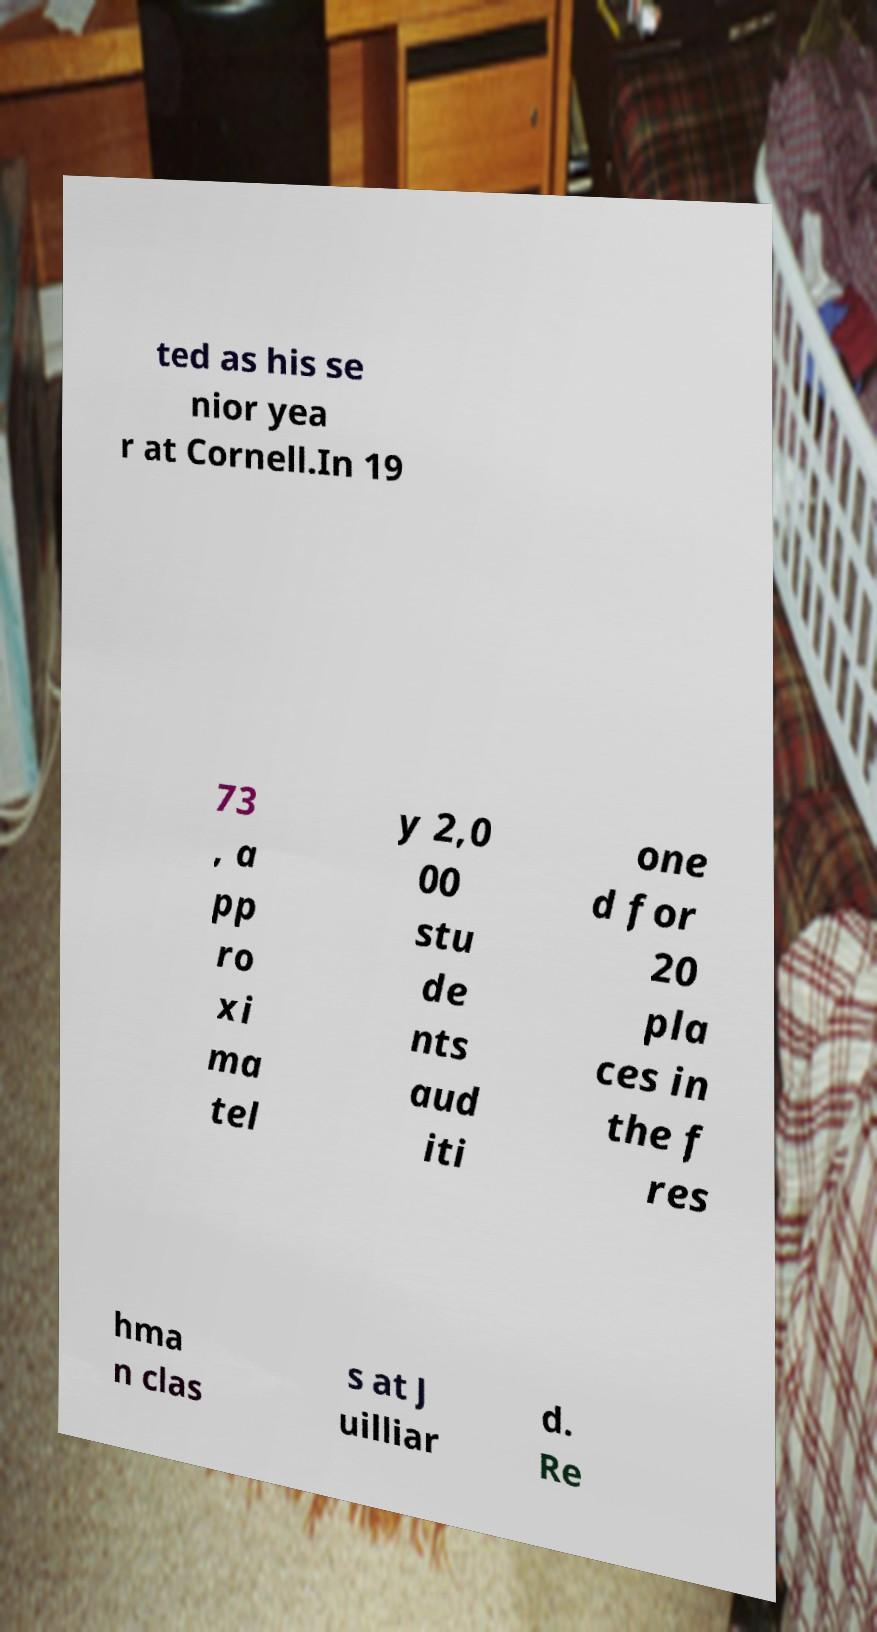What messages or text are displayed in this image? I need them in a readable, typed format. ted as his se nior yea r at Cornell.In 19 73 , a pp ro xi ma tel y 2,0 00 stu de nts aud iti one d for 20 pla ces in the f res hma n clas s at J uilliar d. Re 